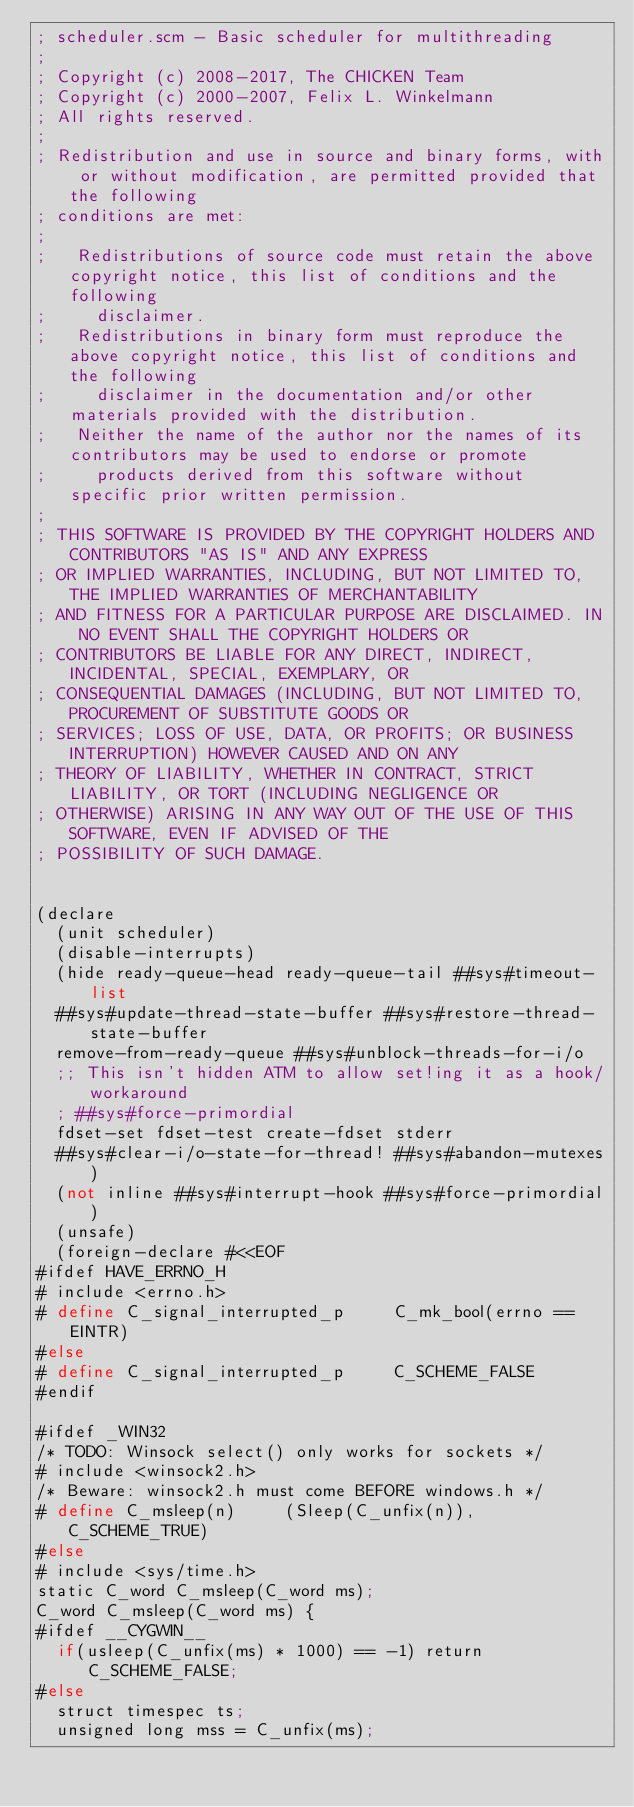Convert code to text. <code><loc_0><loc_0><loc_500><loc_500><_Scheme_>; scheduler.scm - Basic scheduler for multithreading
;
; Copyright (c) 2008-2017, The CHICKEN Team
; Copyright (c) 2000-2007, Felix L. Winkelmann
; All rights reserved.
;
; Redistribution and use in source and binary forms, with or without modification, are permitted provided that the following
; conditions are met:
;
;   Redistributions of source code must retain the above copyright notice, this list of conditions and the following
;     disclaimer. 
;   Redistributions in binary form must reproduce the above copyright notice, this list of conditions and the following
;     disclaimer in the documentation and/or other materials provided with the distribution. 
;   Neither the name of the author nor the names of its contributors may be used to endorse or promote
;     products derived from this software without specific prior written permission. 
;
; THIS SOFTWARE IS PROVIDED BY THE COPYRIGHT HOLDERS AND CONTRIBUTORS "AS IS" AND ANY EXPRESS
; OR IMPLIED WARRANTIES, INCLUDING, BUT NOT LIMITED TO, THE IMPLIED WARRANTIES OF MERCHANTABILITY
; AND FITNESS FOR A PARTICULAR PURPOSE ARE DISCLAIMED. IN NO EVENT SHALL THE COPYRIGHT HOLDERS OR
; CONTRIBUTORS BE LIABLE FOR ANY DIRECT, INDIRECT, INCIDENTAL, SPECIAL, EXEMPLARY, OR
; CONSEQUENTIAL DAMAGES (INCLUDING, BUT NOT LIMITED TO, PROCUREMENT OF SUBSTITUTE GOODS OR
; SERVICES; LOSS OF USE, DATA, OR PROFITS; OR BUSINESS INTERRUPTION) HOWEVER CAUSED AND ON ANY
; THEORY OF LIABILITY, WHETHER IN CONTRACT, STRICT LIABILITY, OR TORT (INCLUDING NEGLIGENCE OR
; OTHERWISE) ARISING IN ANY WAY OUT OF THE USE OF THIS SOFTWARE, EVEN IF ADVISED OF THE
; POSSIBILITY OF SUCH DAMAGE.


(declare
  (unit scheduler)
  (disable-interrupts)
  (hide ready-queue-head ready-queue-tail ##sys#timeout-list
	##sys#update-thread-state-buffer ##sys#restore-thread-state-buffer
	remove-from-ready-queue ##sys#unblock-threads-for-i/o
	;; This isn't hidden ATM to allow set!ing it as a hook/workaround
	; ##sys#force-primordial
	fdset-set fdset-test create-fdset stderr
	##sys#clear-i/o-state-for-thread! ##sys#abandon-mutexes) 
  (not inline ##sys#interrupt-hook ##sys#force-primordial)
  (unsafe)
  (foreign-declare #<<EOF
#ifdef HAVE_ERRNO_H
# include <errno.h>
# define C_signal_interrupted_p     C_mk_bool(errno == EINTR)
#else
# define C_signal_interrupted_p     C_SCHEME_FALSE
#endif

#ifdef _WIN32
/* TODO: Winsock select() only works for sockets */
# include <winsock2.h>
/* Beware: winsock2.h must come BEFORE windows.h */
# define C_msleep(n)     (Sleep(C_unfix(n)), C_SCHEME_TRUE)
#else
# include <sys/time.h>
static C_word C_msleep(C_word ms);
C_word C_msleep(C_word ms) {
#ifdef __CYGWIN__
  if(usleep(C_unfix(ms) * 1000) == -1) return C_SCHEME_FALSE;
#else
  struct timespec ts;
  unsigned long mss = C_unfix(ms);</code> 